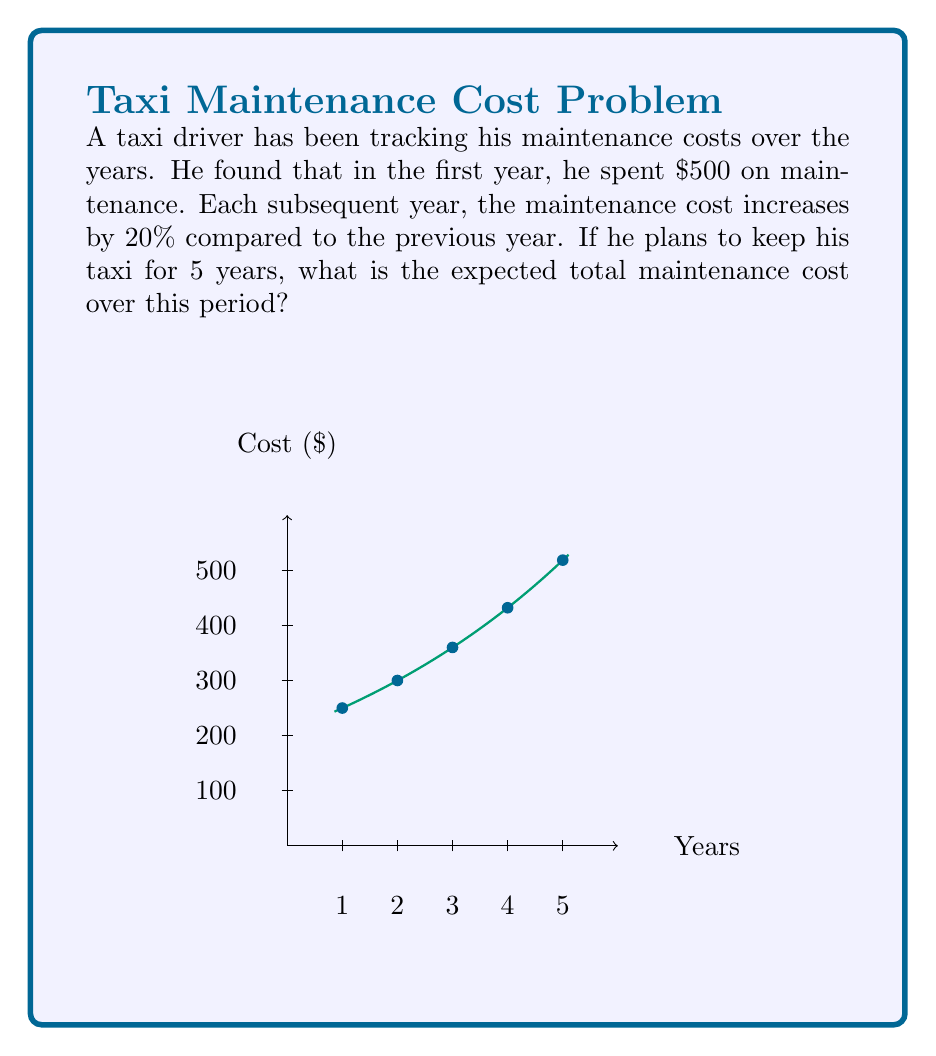Could you help me with this problem? Let's approach this step-by-step:

1) In the first year, the cost is $500.

2) For each subsequent year, we multiply the previous year's cost by 1.2 (a 20% increase).

3) Let's calculate the cost for each year:
   Year 1: $500
   Year 2: $500 * 1.2 = $600
   Year 3: $600 * 1.2 = $720
   Year 4: $720 * 1.2 = $864
   Year 5: $864 * 1.2 = $1,036.80

4) We can express this mathematically as:
   $$C_n = 500 * (1.2)^{n-1}$$
   where $C_n$ is the cost in year $n$.

5) To find the total cost over 5 years, we need to sum these values:
   $$\text{Total Cost} = \sum_{n=1}^5 500 * (1.2)^{n-1}$$

6) This is a geometric series with first term $a=500$ and common ratio $r=1.2$. 
   The sum of a geometric series is given by the formula:
   $$S_n = a\frac{1-r^n}{1-r}$$

7) Plugging in our values:
   $$\text{Total Cost} = 500 * \frac{1-(1.2)^5}{1-1.2}$$

8) Calculating this:
   $$\text{Total Cost} = 500 * \frac{1-2.48832}{-0.2} = 3720.80$$

Therefore, the expected total maintenance cost over 5 years is $3,720.80.
Answer: $3,720.80 